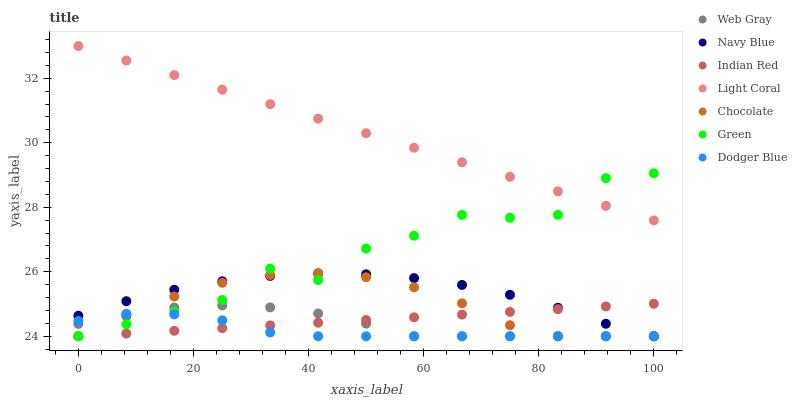Does Dodger Blue have the minimum area under the curve?
Answer yes or no. Yes. Does Light Coral have the maximum area under the curve?
Answer yes or no. Yes. Does Navy Blue have the minimum area under the curve?
Answer yes or no. No. Does Navy Blue have the maximum area under the curve?
Answer yes or no. No. Is Light Coral the smoothest?
Answer yes or no. Yes. Is Green the roughest?
Answer yes or no. Yes. Is Navy Blue the smoothest?
Answer yes or no. No. Is Navy Blue the roughest?
Answer yes or no. No. Does Web Gray have the lowest value?
Answer yes or no. Yes. Does Light Coral have the lowest value?
Answer yes or no. No. Does Light Coral have the highest value?
Answer yes or no. Yes. Does Navy Blue have the highest value?
Answer yes or no. No. Is Web Gray less than Light Coral?
Answer yes or no. Yes. Is Light Coral greater than Navy Blue?
Answer yes or no. Yes. Does Light Coral intersect Green?
Answer yes or no. Yes. Is Light Coral less than Green?
Answer yes or no. No. Is Light Coral greater than Green?
Answer yes or no. No. Does Web Gray intersect Light Coral?
Answer yes or no. No. 